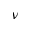Convert formula to latex. <formula><loc_0><loc_0><loc_500><loc_500>\nu</formula> 